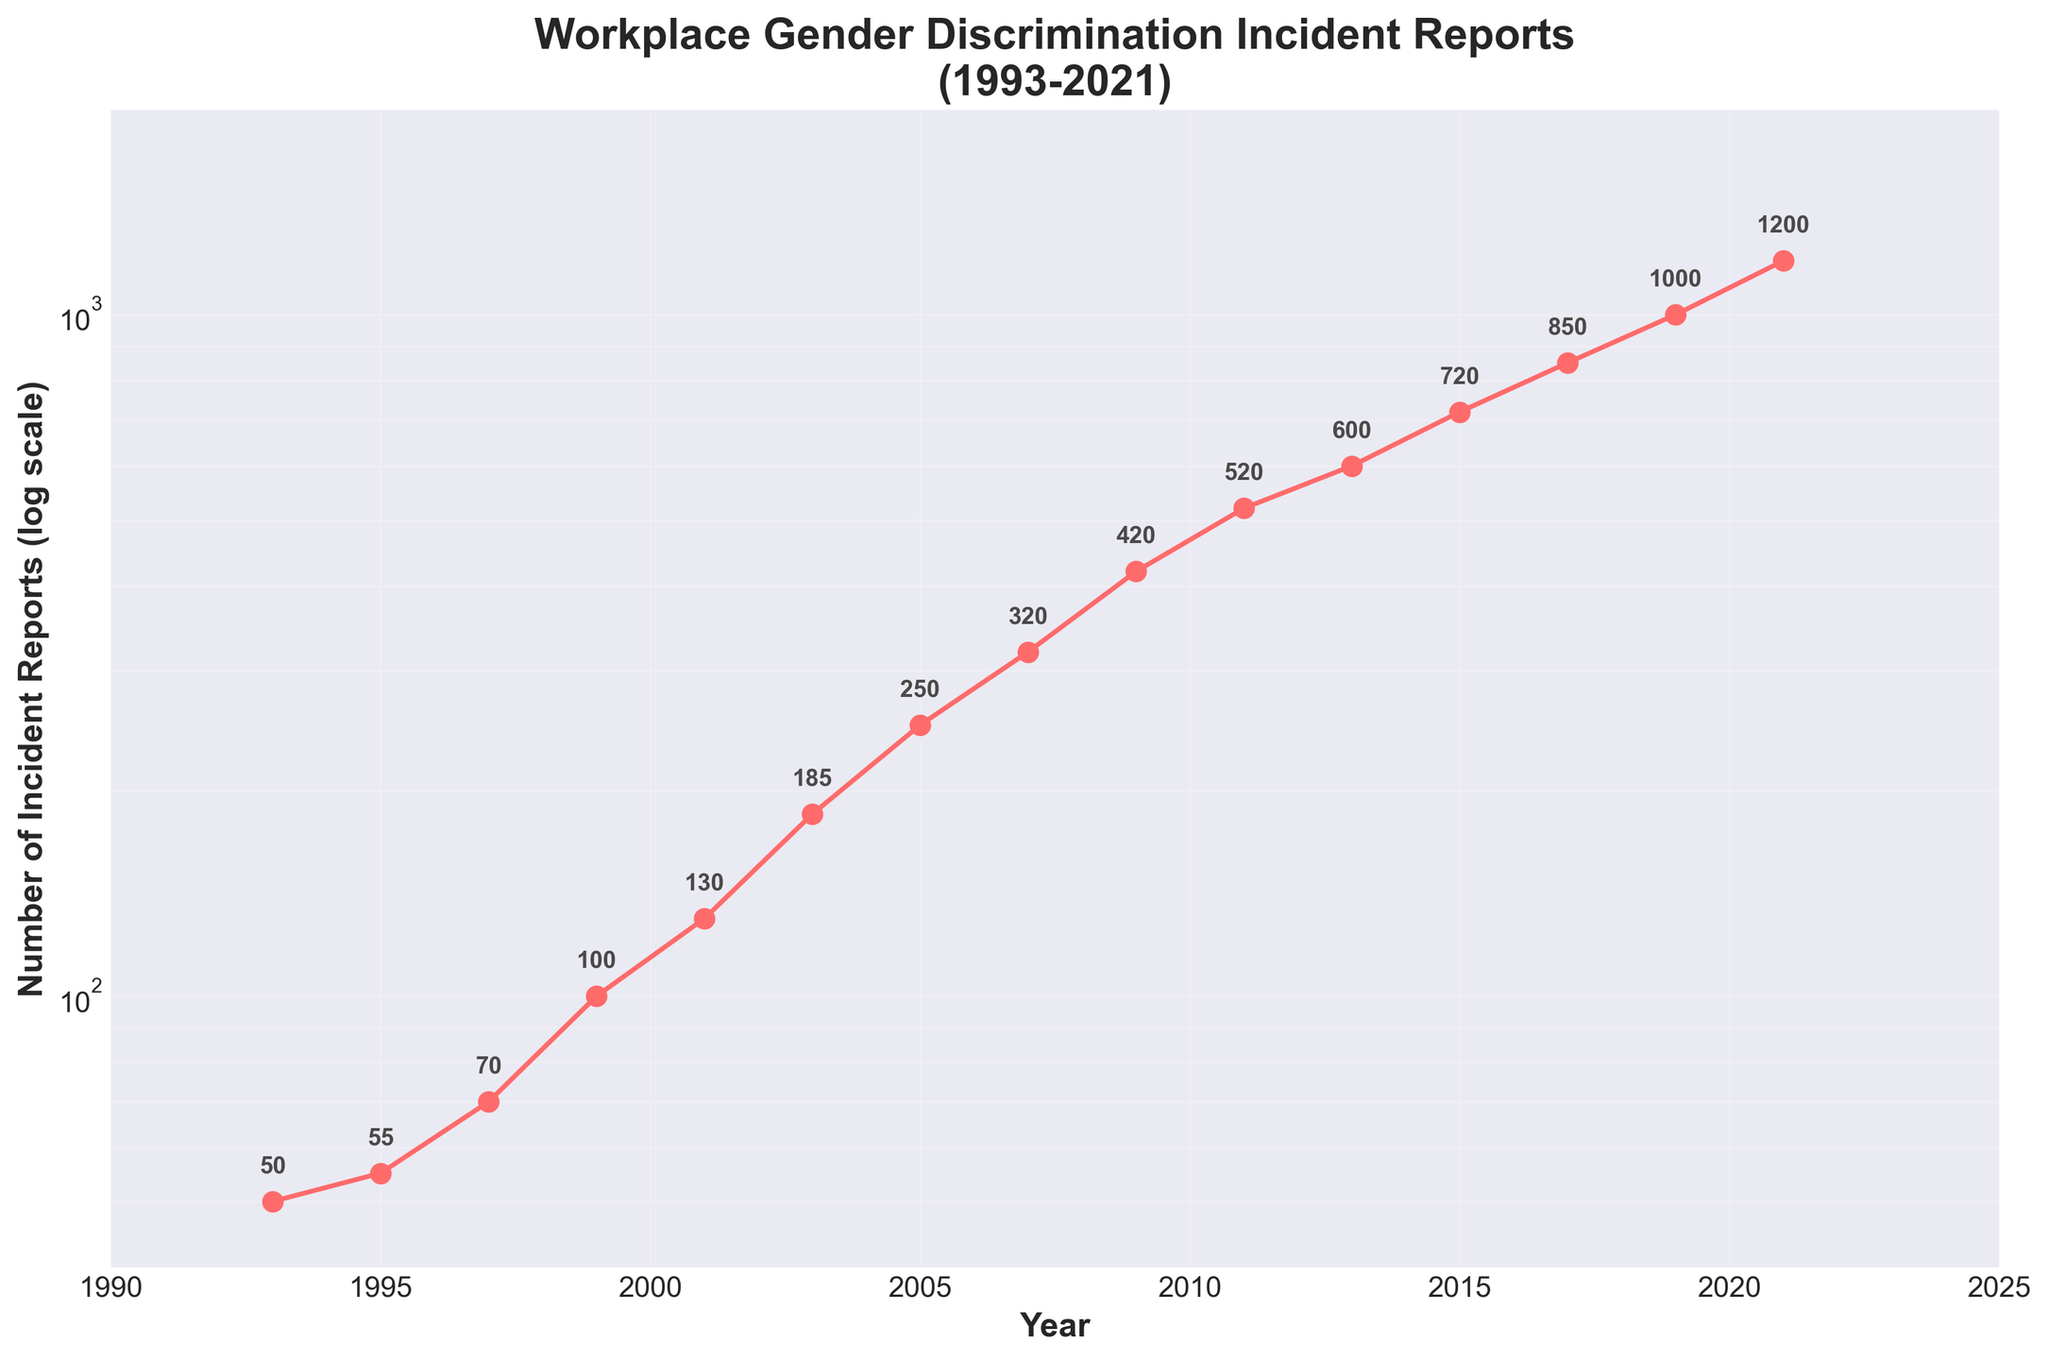What is the title of the figure? The title of the figure is prominently displayed at the top.
Answer: Workplace Gender Discrimination Incident Reports (1993-2021) How many data points are plotted on the figure? By counting the number of points marked on the plot, we can see there are 15 data points, each representing a year.
Answer: 15 Which year has the highest number of incident reports? By observing the highest point on the vertical axis (log scale), we see that 2021 has the highest number of incident reports.
Answer: 2021 What is the trend of incident reports from 2005 to 2009? Looking at the plot from 2005 to 2009, we notice a continuous increase in the number of incident reports.
Answer: Increasing What was the number of incident reports in 2011? By checking the point labeled 2011 on the plot, we find the number next to it is 520.
Answer: 520 By how much did the number of incident reports increase from 1993 to 1999? The number of incident reports in 1993 was 50, and in 1999 it was 100. By subtracting 50 from 100, we find the increase.
Answer: 50 Between which consecutive years was the highest increase in incident reports observed? By examining the differences between the consecutive data points, the largest jump, visually, is between 2001 (130) and 2003 (185). The difference is 55.
Answer: 2001 and 2003 Which year shows a steeper increase in incident reports, 2009 to 2011 or 2011 to 2013? From the figure, comparing the slopes, the increase from 2009 (420) to 2011 (520) is 100, and from 2011 (520) to 2013 (600) is 80. Thus, the increase from 2009 to 2011 is steeper.
Answer: 2009 to 2011 Why is the y-axis in the plot displayed in a log scale? The log scale is used to clearly show the increases over time without compressing the larger values too much, making it easier to see trends even with exponential growth.
Answer: To show exponential growth What is the average number of incident reports per year from 2015 to 2021? The values from 2015 to 2021 are 720, 850, 1000, and 1200. Adding these gives 3770. Dividing by 4 (number of years) gives the average.
Answer: 942.5 What was the rate of increase in incident reports from 1993 to 1997? The number of reports in 1993 was 50 and in 1997 it was 70. The rate of increase is (70 - 50) / (1997 - 1993) = 20 / 4 = 5 reports per year.
Answer: 5 reports per year 